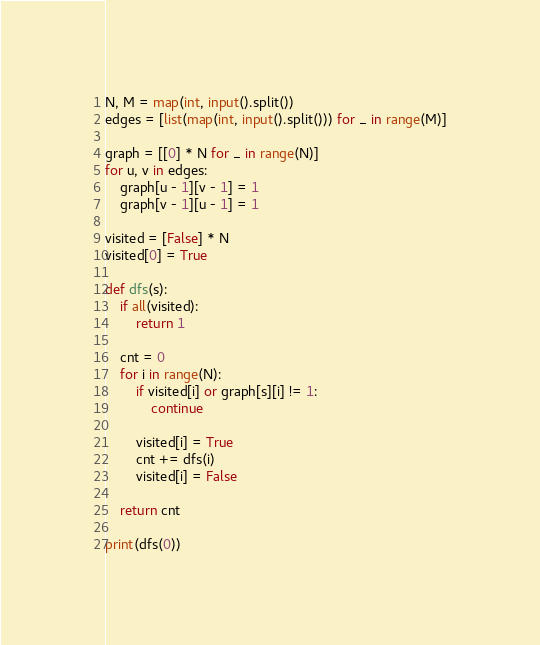<code> <loc_0><loc_0><loc_500><loc_500><_Python_>N, M = map(int, input().split())
edges = [list(map(int, input().split())) for _ in range(M)]

graph = [[0] * N for _ in range(N)]
for u, v in edges:
    graph[u - 1][v - 1] = 1
    graph[v - 1][u - 1] = 1

visited = [False] * N
visited[0] = True

def dfs(s):    
    if all(visited):
        return 1

    cnt = 0
    for i in range(N):
        if visited[i] or graph[s][i] != 1:
            continue
            
        visited[i] = True
        cnt += dfs(i)
        visited[i] = False
        
    return cnt

print(dfs(0))

</code> 